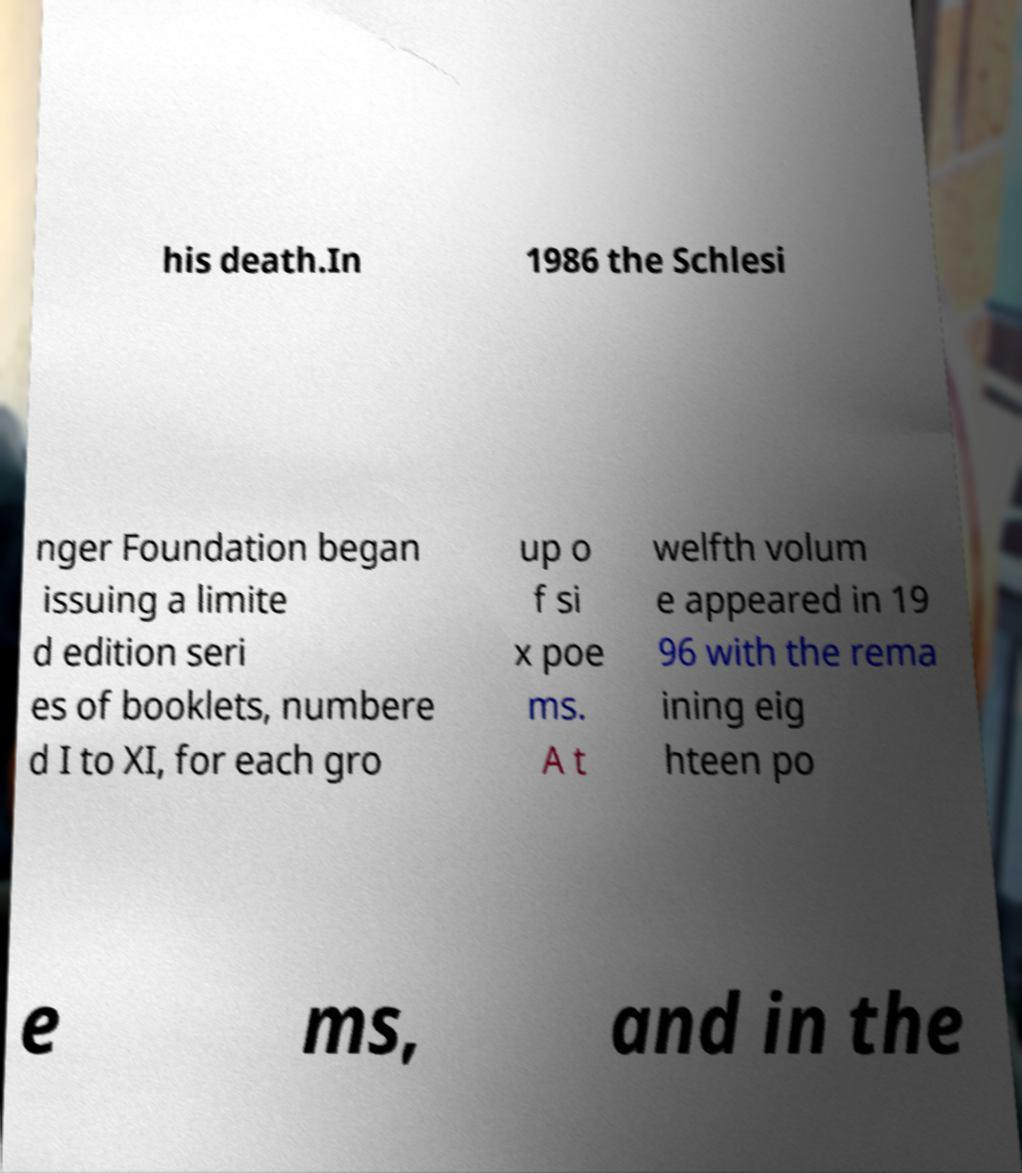There's text embedded in this image that I need extracted. Can you transcribe it verbatim? his death.In 1986 the Schlesi nger Foundation began issuing a limite d edition seri es of booklets, numbere d I to XI, for each gro up o f si x poe ms. A t welfth volum e appeared in 19 96 with the rema ining eig hteen po e ms, and in the 